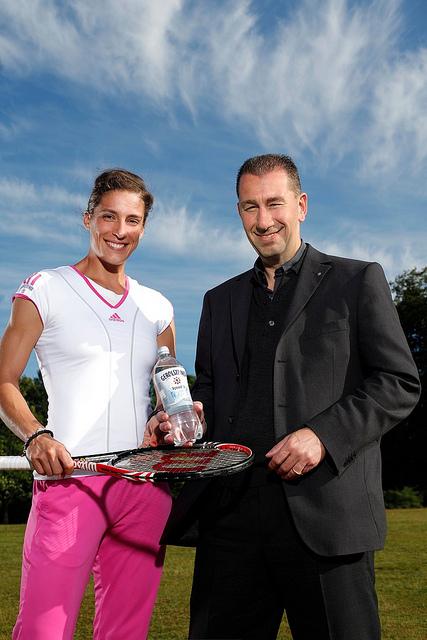What brand racket?
Keep it brief. Wilson. What color are the lady's pants?
Answer briefly. Pink. Is the couple smiling?
Be succinct. Yes. 